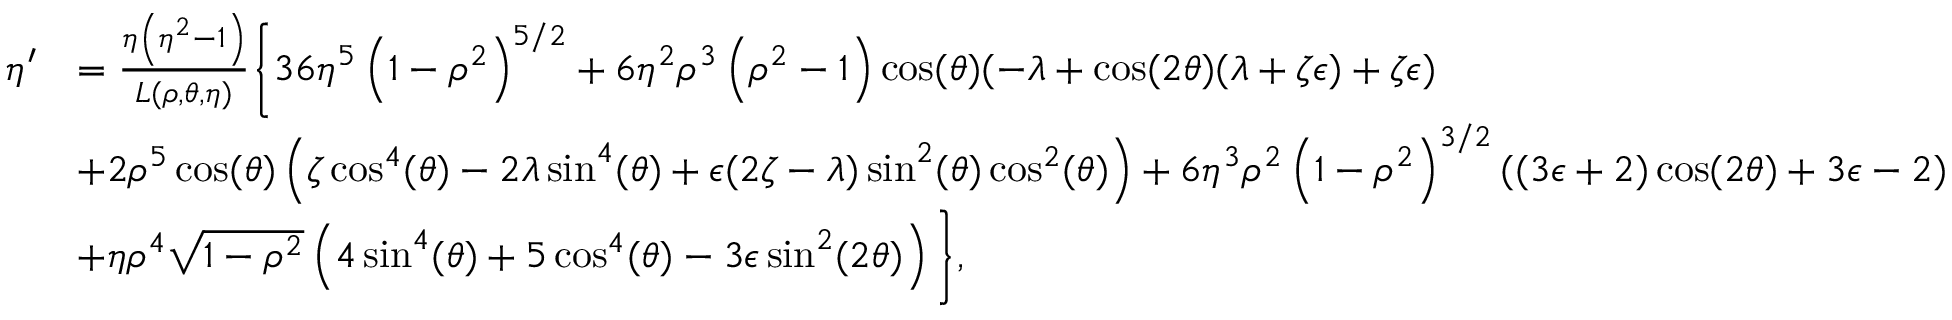Convert formula to latex. <formula><loc_0><loc_0><loc_500><loc_500>\begin{array} { r l } { \eta ^ { \prime } } & { = \frac { \eta \left ( \eta ^ { 2 } - 1 \right ) } { L ( \rho , \theta , \eta ) } \left \{ 3 6 \eta ^ { 5 } \left ( 1 - \rho ^ { 2 } \right ) ^ { 5 / 2 } + 6 \eta ^ { 2 } \rho ^ { 3 } \left ( \rho ^ { 2 } - 1 \right ) \cos ( \theta ) ( - \lambda + \cos ( 2 \theta ) ( \lambda + \zeta \epsilon ) + \zeta \epsilon ) } \\ & { + 2 \rho ^ { 5 } \cos ( \theta ) \left ( \zeta \cos ^ { 4 } ( \theta ) - 2 \lambda \sin ^ { 4 } ( \theta ) + \epsilon ( 2 \zeta - \lambda ) \sin ^ { 2 } ( \theta ) \cos ^ { 2 } ( \theta ) \right ) + 6 \eta ^ { 3 } \rho ^ { 2 } \left ( 1 - \rho ^ { 2 } \right ) ^ { 3 / 2 } ( ( 3 \epsilon + 2 ) \cos ( 2 \theta ) + 3 \epsilon - 2 ) } \\ & { + \eta \rho ^ { 4 } \sqrt { 1 - \rho ^ { 2 } } \left ( 4 \sin ^ { 4 } ( \theta ) + 5 \cos ^ { 4 } ( \theta ) - 3 \epsilon \sin ^ { 2 } ( 2 \theta ) \right ) \right \} , } \end{array}</formula> 